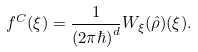<formula> <loc_0><loc_0><loc_500><loc_500>f ^ { C } ( \xi ) = \frac { 1 } { ( 2 \pi \hbar { ) } ^ { d } } W _ { \xi } ( \hat { \rho } ) ( \xi ) .</formula> 